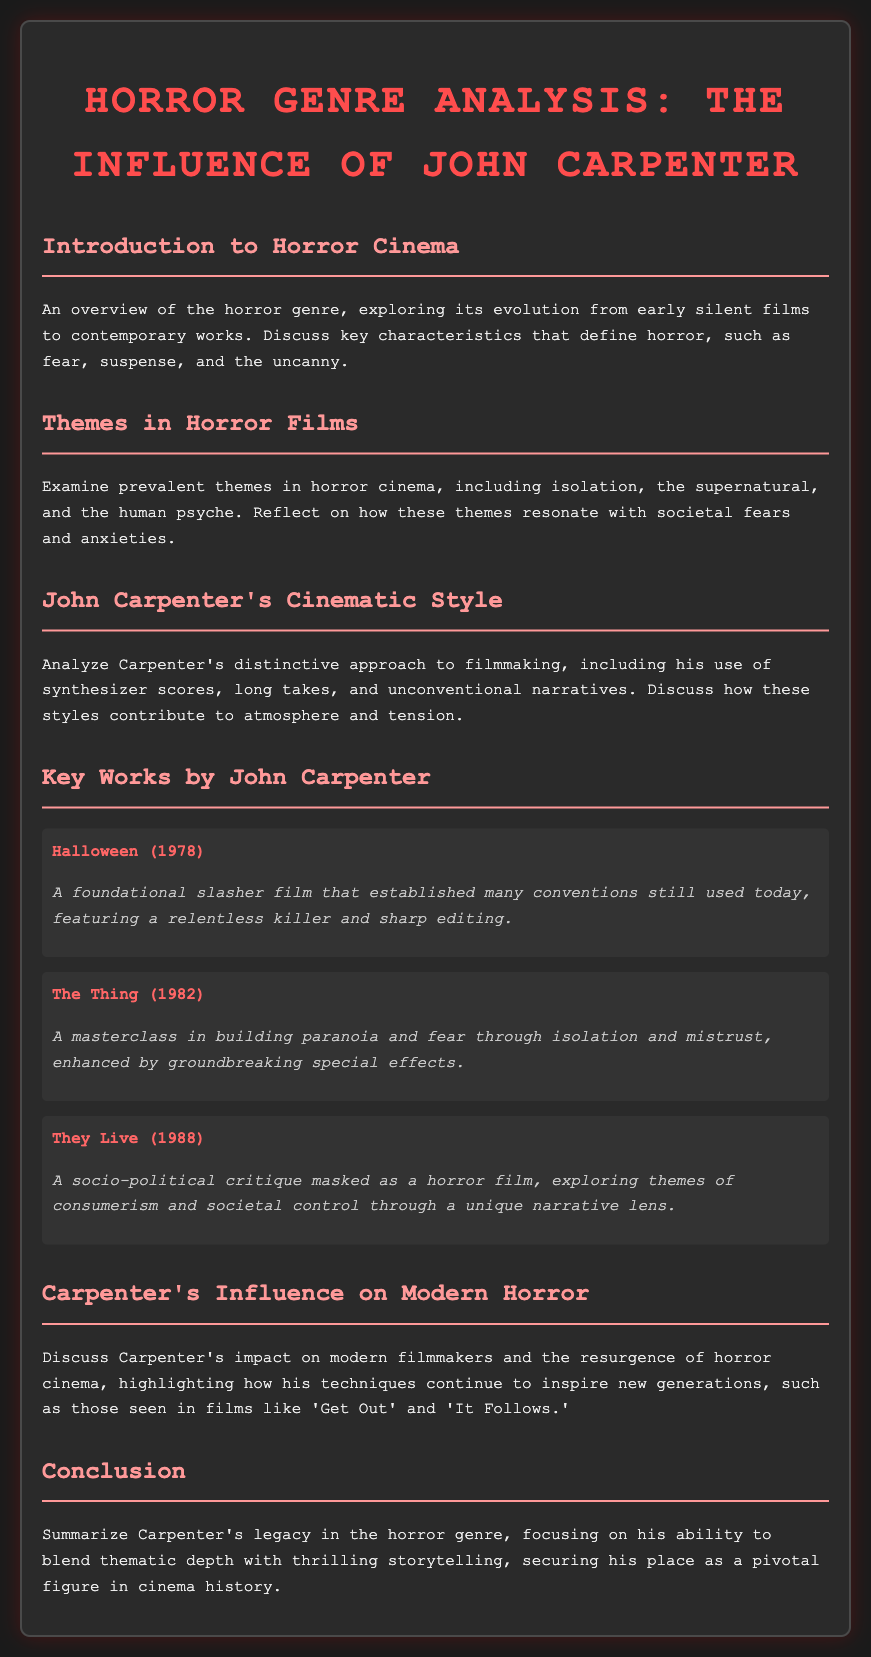What is the title of the document? The title is explicitly stated at the top of the document, which discusses horror genre analysis and John Carpenter's influence.
Answer: Horror Genre Analysis: The Influence of John Carpenter Which year was "Halloween" released? The specific year of release for "Halloween" is mentioned in the key works section of the document.
Answer: 1978 What primary theme is explored in horror cinema according to the document? The document highlights prevalent themes in horror cinema and identifies 'isolation' as one of them.
Answer: Isolation What cinematic element does Carpenter frequently use in his films? The document mentions specific stylistic choices of Carpenter, among which synthesizer scores are highlighted.
Answer: Synthesizer scores Which film is noted for building paranoia through isolation? The document describes "The Thing" as a masterclass in building paranoia and fear through isolation.
Answer: The Thing What socio-political theme does "They Live" critique? The document specifies that "They Live" explores themes of societal control masked as horror.
Answer: Societal control Name one modern film influenced by Carpenter’s techniques. The document provides examples of modern films influenced by Carpenter’s style, including "Get Out."
Answer: Get Out How does the document classify "Halloween"? The document describes "Halloween" as a foundational slasher film, establishing various conventions in the horror genre.
Answer: Foundational slasher film What is the overall conclusion regarding Carpenter's legacy? The conclusion summarizes Carpenter's ability to blend thematic depth with storytelling in horror cinema.
Answer: Thematic depth with thrilling storytelling 